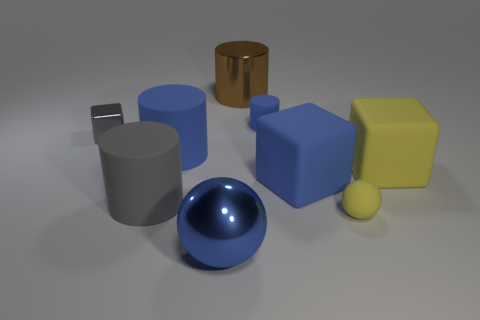Subtract all large cubes. How many cubes are left? 1 Subtract all brown cylinders. How many cylinders are left? 3 Subtract all cubes. How many objects are left? 6 Add 2 spheres. How many spheres exist? 4 Subtract 0 purple cylinders. How many objects are left? 9 Subtract 3 cylinders. How many cylinders are left? 1 Subtract all red cubes. Subtract all yellow cylinders. How many cubes are left? 3 Subtract all yellow blocks. How many green cylinders are left? 0 Subtract all small rubber cylinders. Subtract all large metallic cylinders. How many objects are left? 7 Add 2 small things. How many small things are left? 5 